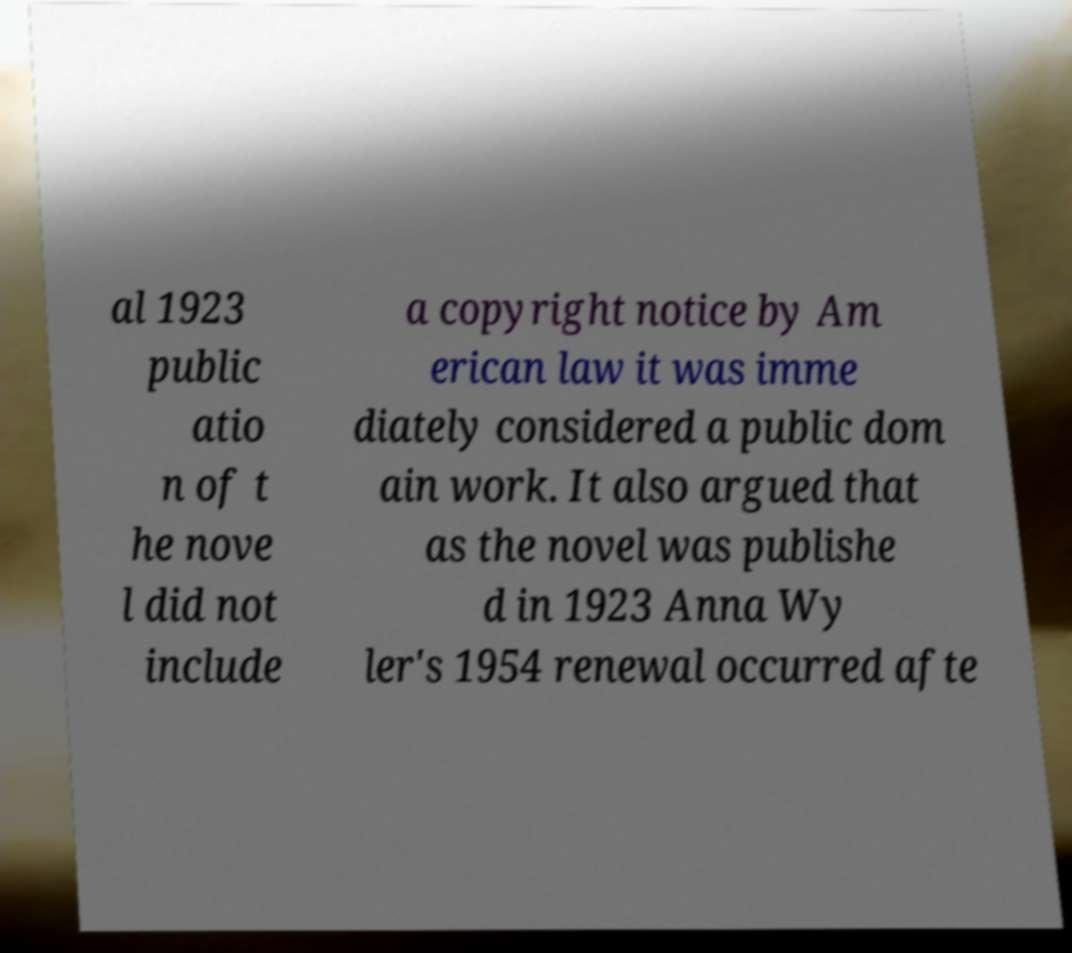I need the written content from this picture converted into text. Can you do that? al 1923 public atio n of t he nove l did not include a copyright notice by Am erican law it was imme diately considered a public dom ain work. It also argued that as the novel was publishe d in 1923 Anna Wy ler's 1954 renewal occurred afte 